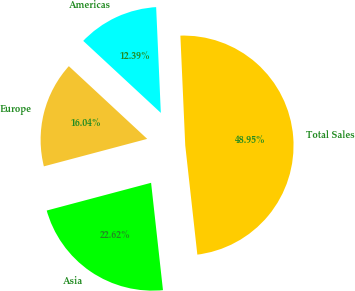Convert chart. <chart><loc_0><loc_0><loc_500><loc_500><pie_chart><fcel>Americas<fcel>Europe<fcel>Asia<fcel>Total Sales<nl><fcel>12.39%<fcel>16.04%<fcel>22.62%<fcel>48.95%<nl></chart> 